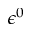Convert formula to latex. <formula><loc_0><loc_0><loc_500><loc_500>\epsilon ^ { 0 }</formula> 